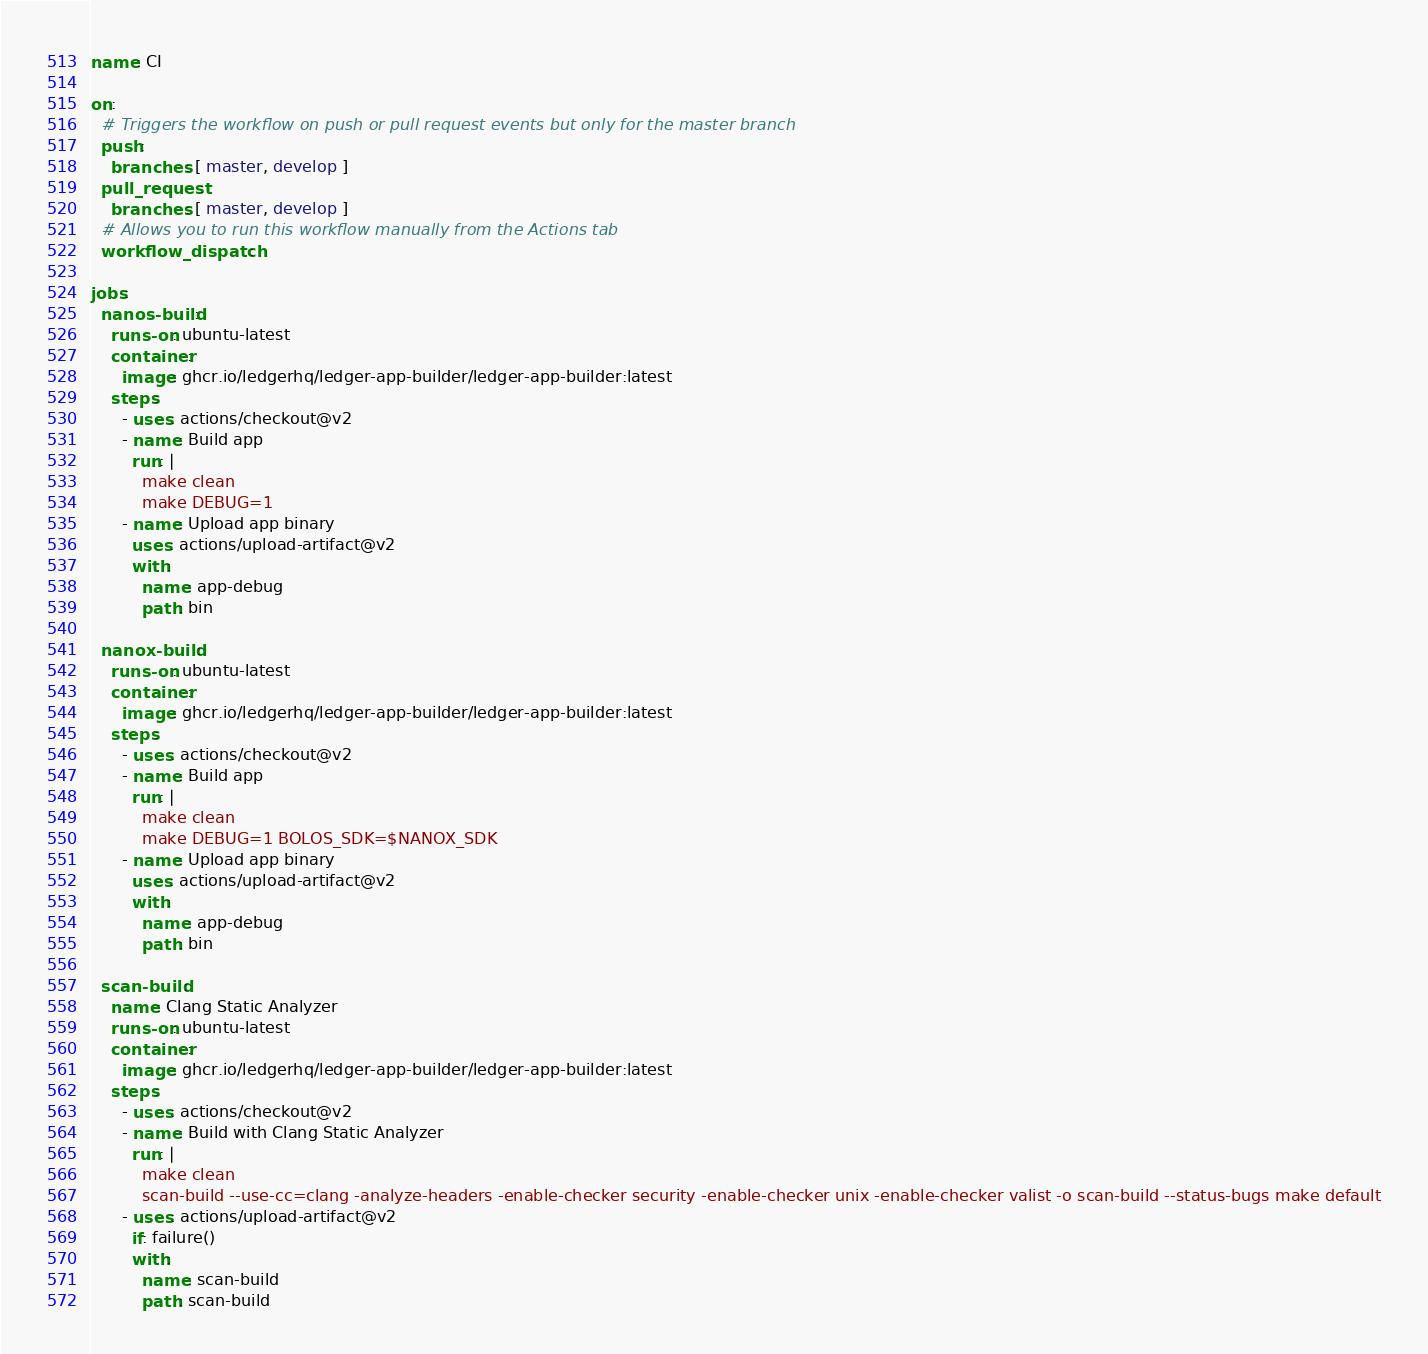<code> <loc_0><loc_0><loc_500><loc_500><_YAML_>name: CI

on:
  # Triggers the workflow on push or pull request events but only for the master branch
  push:
    branches: [ master, develop ]
  pull_request:
    branches: [ master, develop ]
  # Allows you to run this workflow manually from the Actions tab
  workflow_dispatch:

jobs:
  nanos-build:
    runs-on: ubuntu-latest
    container:
      image: ghcr.io/ledgerhq/ledger-app-builder/ledger-app-builder:latest
    steps:
      - uses: actions/checkout@v2
      - name: Build app
        run: |
          make clean
          make DEBUG=1
      - name: Upload app binary
        uses: actions/upload-artifact@v2
        with:
          name: app-debug
          path: bin

  nanox-build:
    runs-on: ubuntu-latest
    container:
      image: ghcr.io/ledgerhq/ledger-app-builder/ledger-app-builder:latest
    steps:
      - uses: actions/checkout@v2
      - name: Build app
        run: |
          make clean
          make DEBUG=1 BOLOS_SDK=$NANOX_SDK
      - name: Upload app binary
        uses: actions/upload-artifact@v2
        with:
          name: app-debug
          path: bin

  scan-build:
    name: Clang Static Analyzer
    runs-on: ubuntu-latest
    container:
      image: ghcr.io/ledgerhq/ledger-app-builder/ledger-app-builder:latest
    steps:
      - uses: actions/checkout@v2
      - name: Build with Clang Static Analyzer
        run: |
          make clean
          scan-build --use-cc=clang -analyze-headers -enable-checker security -enable-checker unix -enable-checker valist -o scan-build --status-bugs make default
      - uses: actions/upload-artifact@v2
        if: failure()
        with:
          name: scan-build
          path: scan-build
</code> 